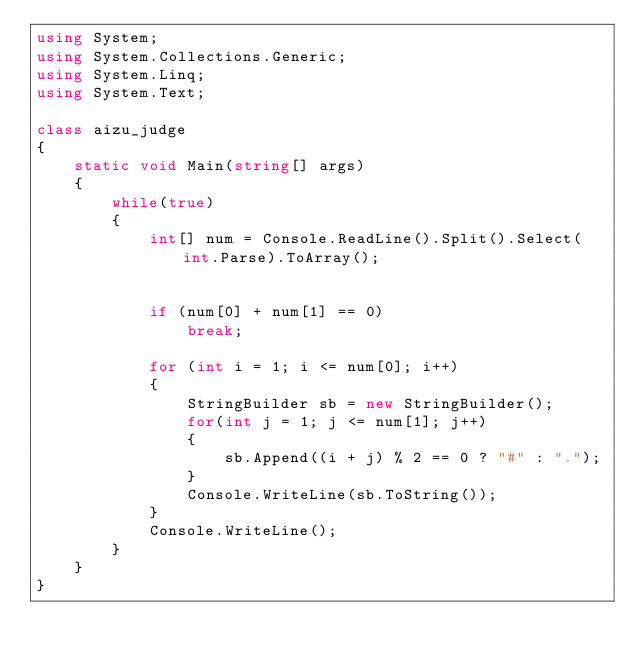<code> <loc_0><loc_0><loc_500><loc_500><_C#_>using System;
using System.Collections.Generic;
using System.Linq;
using System.Text;

class aizu_judge
{
    static void Main(string[] args)
    {
        while(true)
        {
            int[] num = Console.ReadLine().Split().Select(int.Parse).ToArray();


            if (num[0] + num[1] == 0)
                break;

            for (int i = 1; i <= num[0]; i++)
            {
                StringBuilder sb = new StringBuilder();
                for(int j = 1; j <= num[1]; j++)
                {
                    sb.Append((i + j) % 2 == 0 ? "#" : ".");
                }
                Console.WriteLine(sb.ToString());
            }
            Console.WriteLine();
        }
    }
}</code> 